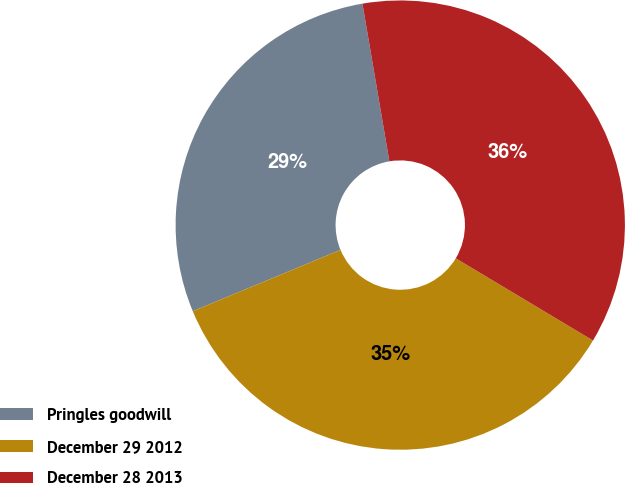<chart> <loc_0><loc_0><loc_500><loc_500><pie_chart><fcel>Pringles goodwill<fcel>December 29 2012<fcel>December 28 2013<nl><fcel>28.57%<fcel>35.15%<fcel>36.28%<nl></chart> 